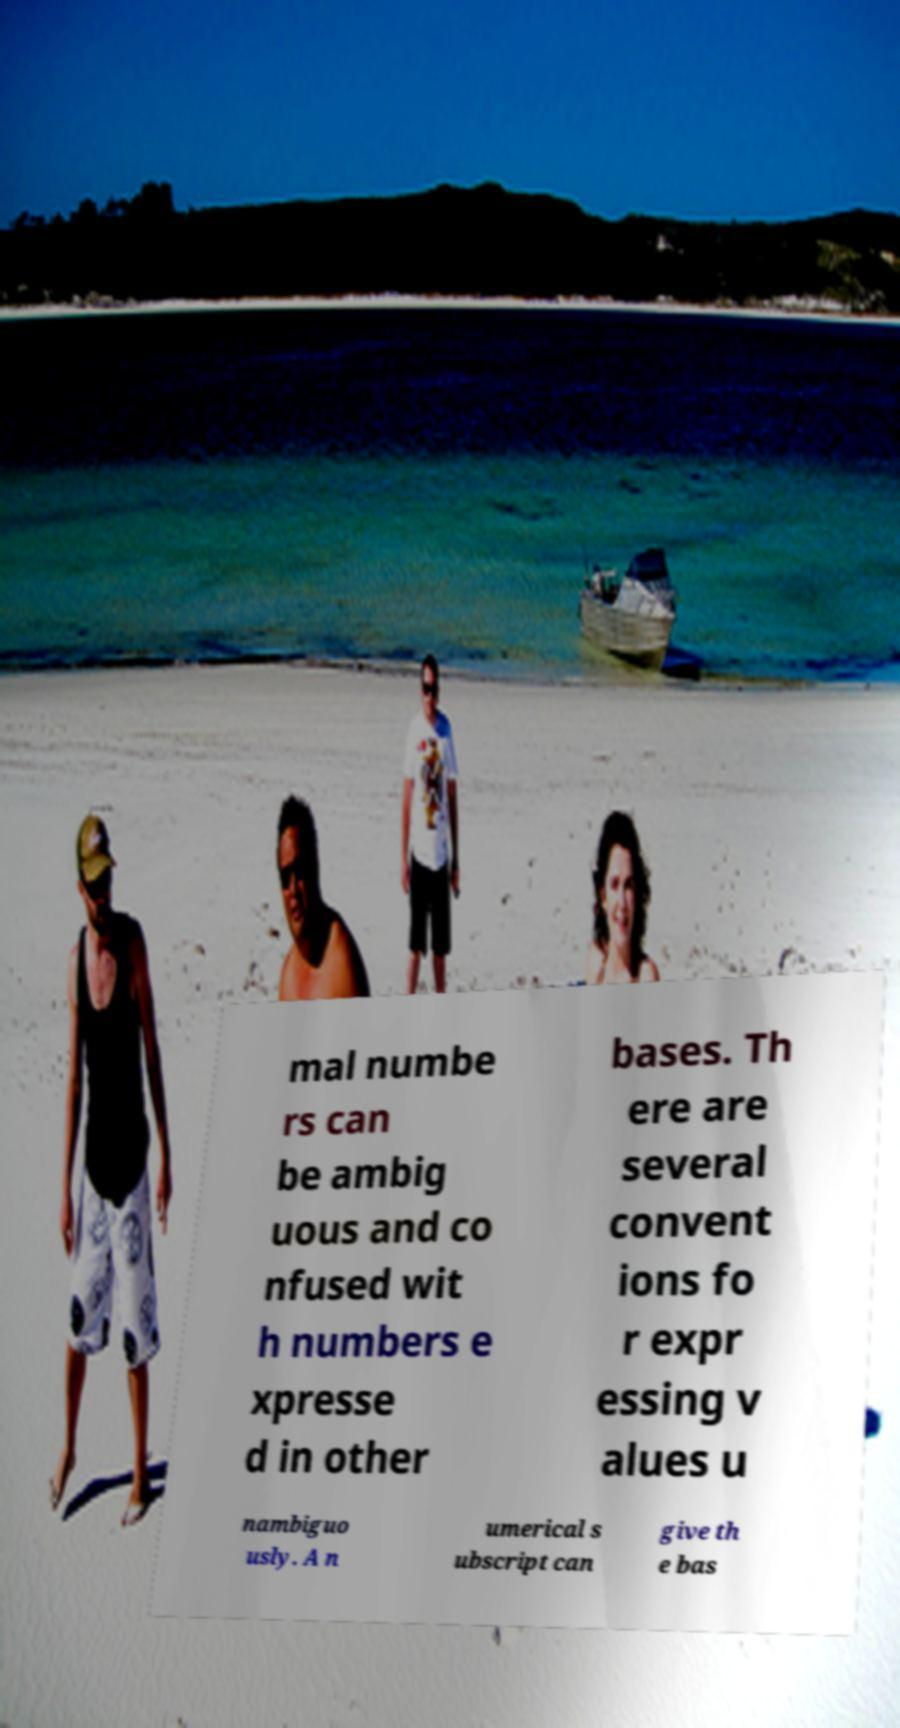Can you accurately transcribe the text from the provided image for me? mal numbe rs can be ambig uous and co nfused wit h numbers e xpresse d in other bases. Th ere are several convent ions fo r expr essing v alues u nambiguo usly. A n umerical s ubscript can give th e bas 